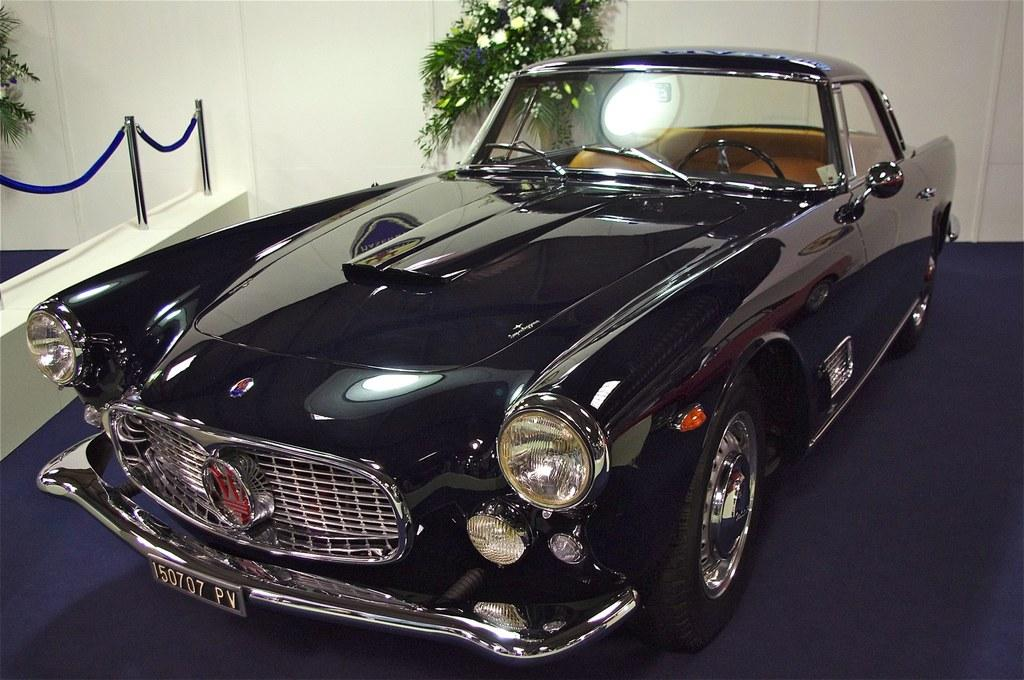What color is the vehicle in the image? The vehicle in the image is black-colored. What is located to the left of the vehicle? There are poles and a ribbon to the left of the vehicle. What can be seen in the background of the image? There are plants and a white wall in the background of the image. How many books are stacked on the vehicle in the image? There are no books visible in the image; it only shows a black-colored vehicle, poles, a ribbon, plants, and a white wall in the background. 